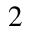Convert formula to latex. <formula><loc_0><loc_0><loc_500><loc_500>2</formula> 